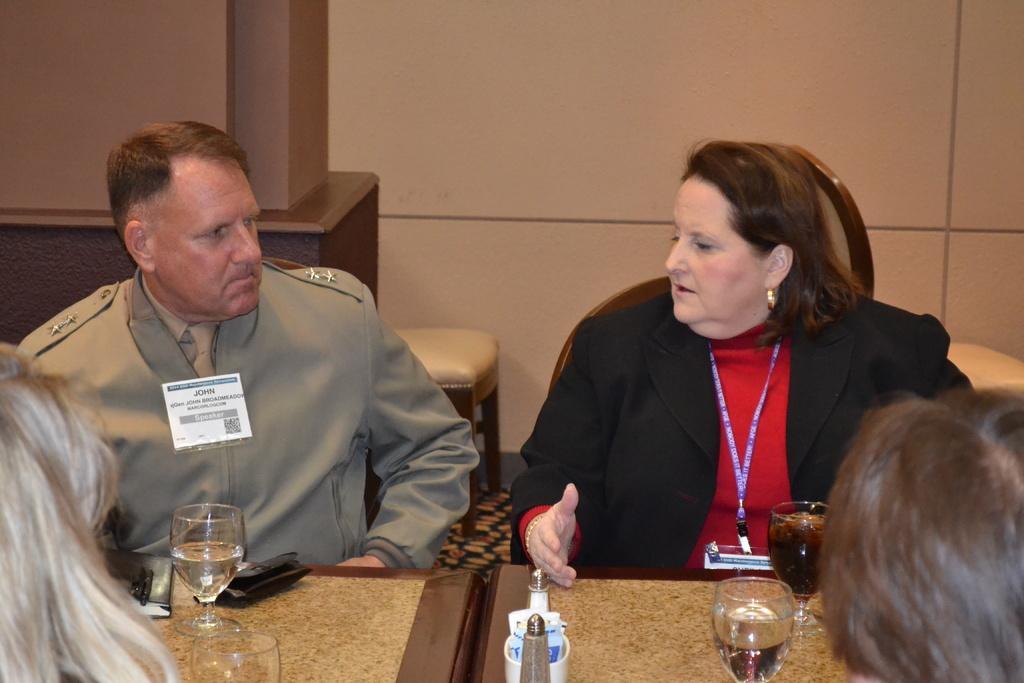Could you give a brief overview of what you see in this image? In the foreground of this image, there is a woman and a man sitting near a table on which glasses, book, pen and a box, cups on the table. On right and left bottom corner, there is a head of a person. On top, there is a wall and stools. 